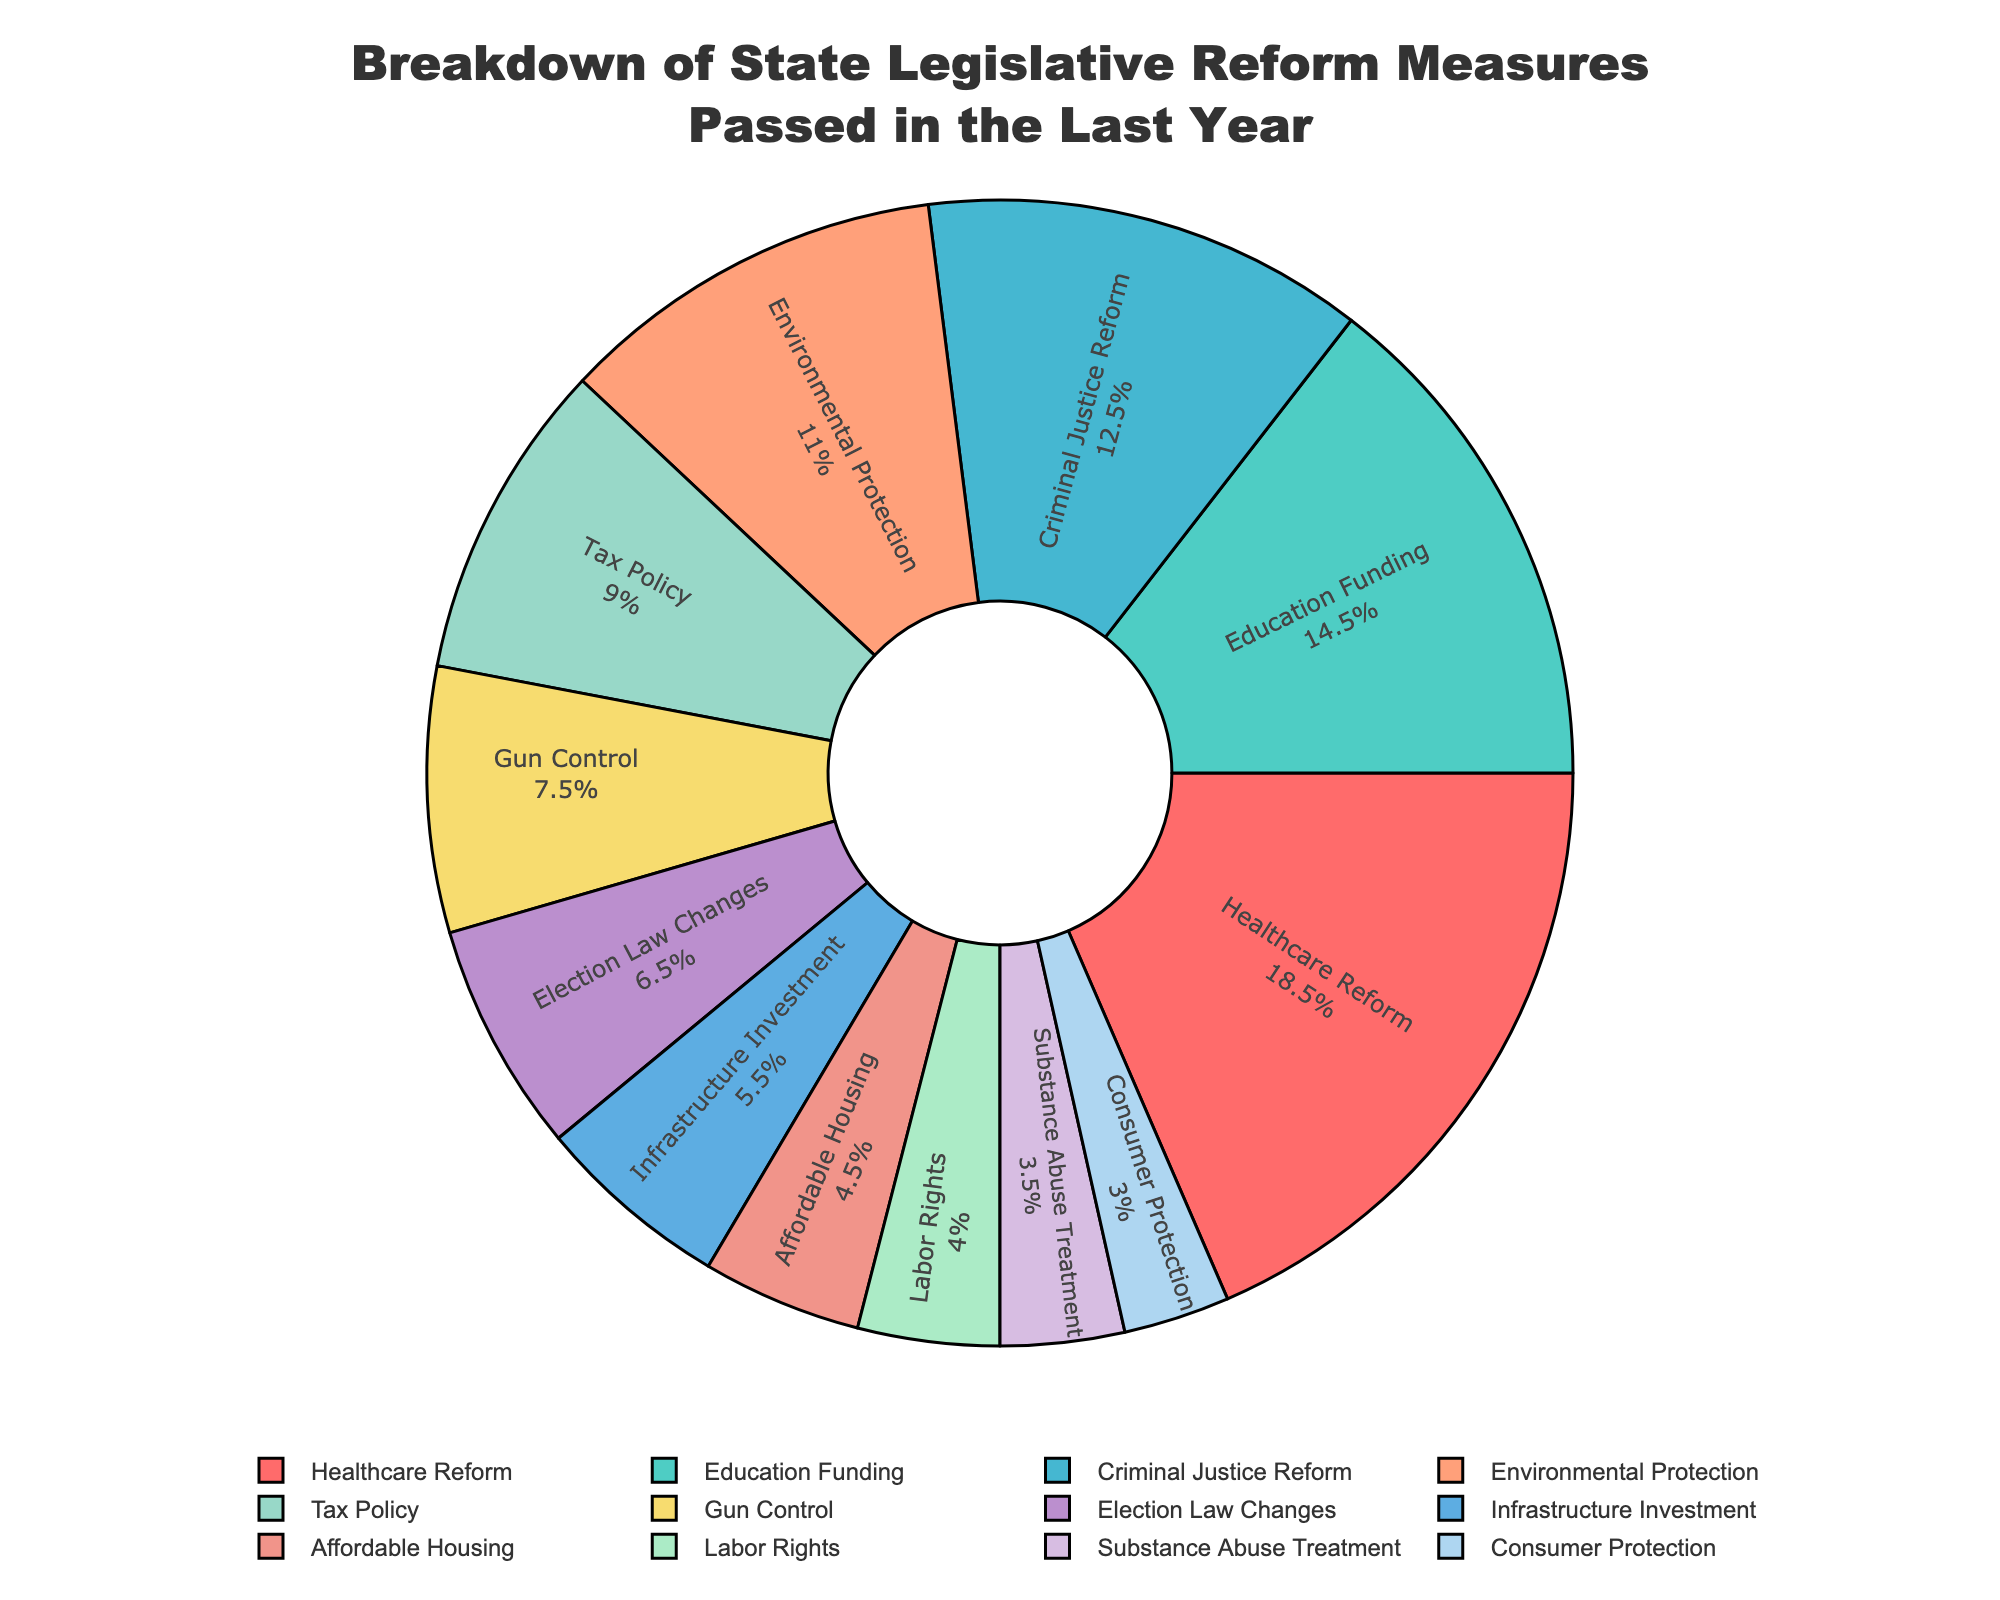What policy area had the highest number of measures passed? The sector with the highest number of measures passed can be identified by looking for the largest segment in the pie chart. In this case, the largest segment represents Healthcare Reform.
Answer: Healthcare Reform Which two policy areas have the closest number of measures passed? By inspecting the size of the segments, we can see that Labor Rights and Substance Abuse Treatment have relatively small and closely sized segments, representing 8 and 7 measures respectively.
Answer: Labor Rights and Substance Abuse Treatment What percentage of the passed measures did Healthcare Reform account for? To determine the percentage, we look at the pie chart where Healthcare Reform is labeled. It shows both the label and the percentage inside the segment.
Answer: 20.3% How many more measures were passed in the policy area of Education Funding compared to Labor Rights? Find the difference between Education Funding and Labor Rights by comparing their segments. Education Funding has 29 measures, and Labor Rights has 8 measures. The difference is 29 - 8 = 21.
Answer: 21 Is the number of measures passed for Election Law Changes greater than criminal justice reform measures? By comparing the size of the segments in the pie chart, it is evident that Criminal Justice Reform, with 25 measures passed, has a larger segment compared to Election Law Changes, with only 13 measures.
Answer: No What is the combined number of measures passed in the areas of Affordable Housing and Gun Control? We need to add the number of measures for Affordable Housing (9) and Gun Control (15). The sum is 9 + 15 = 24.
Answer: 24 Which policy area accounts for the smallest portion of measures passed? By examining the smallest segment on the pie chart, we observe that Consumer Protection represents the least number of measures passed.
Answer: Consumer Protection How does the number of Tax Policy measures passed compare to Environmental Protection measures? By comparing the size of their segments, we see that Tax Policy has 18 measures passed, while Environmental Protection has 22 measures. So, Environmental Protection is greater.
Answer: Environmental Protection If you combine Criminal Justice Reform and Healthcare Reform, how many measures would that account for? Sum up the measures passed for Criminal Justice Reform (25) and Healthcare Reform (37). The total is 25 + 37 = 62.
Answer: 62 